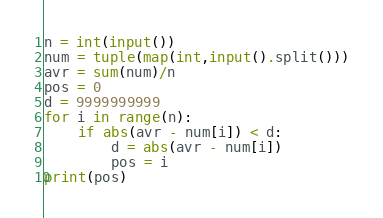Convert code to text. <code><loc_0><loc_0><loc_500><loc_500><_Python_>n = int(input())
num = tuple(map(int,input().split()))
avr = sum(num)/n
pos = 0
d = 9999999999
for i in range(n):
    if abs(avr - num[i]) < d:
        d = abs(avr - num[i])
        pos = i
print(pos)
</code> 